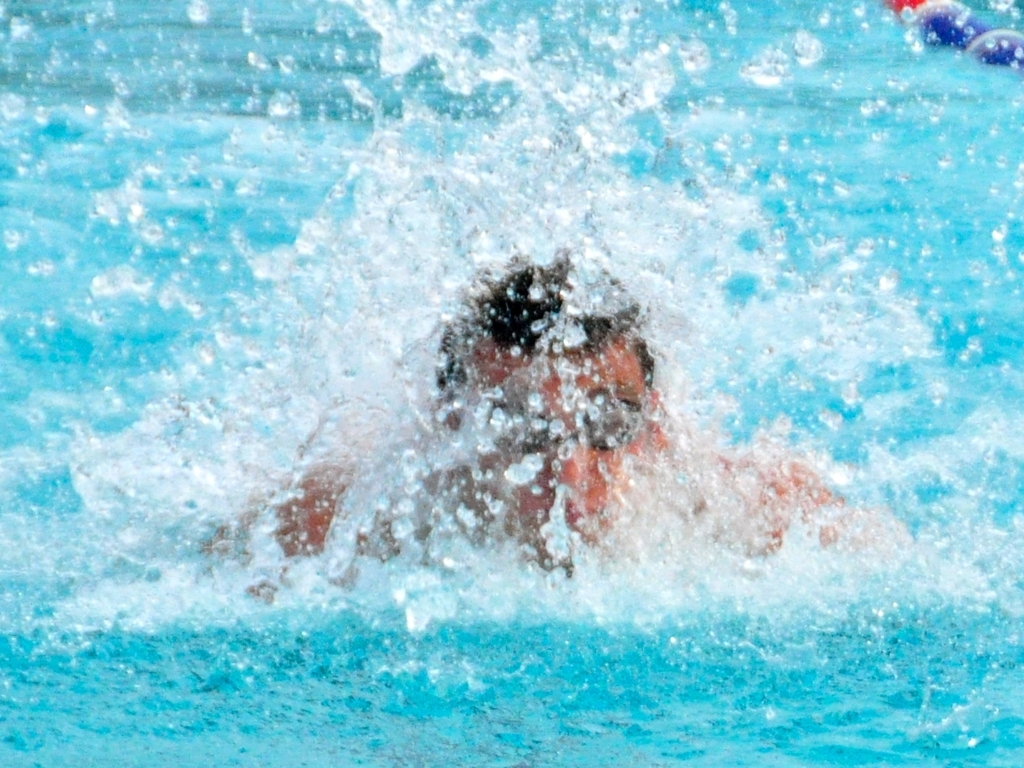Does the photo capture the moment when the athlete splashes in the water? Indeed, the photo vividly captures the intense moment an athlete makes a splash, with water droplets dispersed around, indicating a dynamic movement likely from diving or swimming vigorously. 